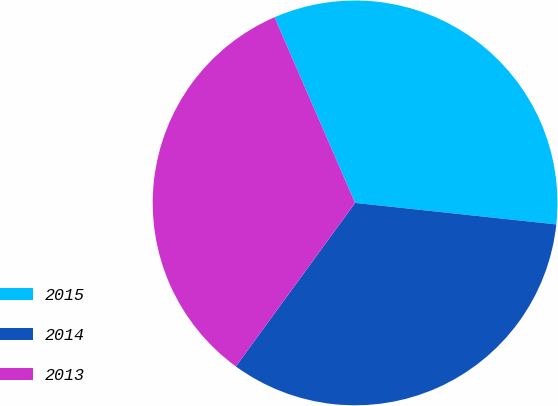<chart> <loc_0><loc_0><loc_500><loc_500><pie_chart><fcel>2015<fcel>2014<fcel>2013<nl><fcel>33.21%<fcel>33.33%<fcel>33.46%<nl></chart> 